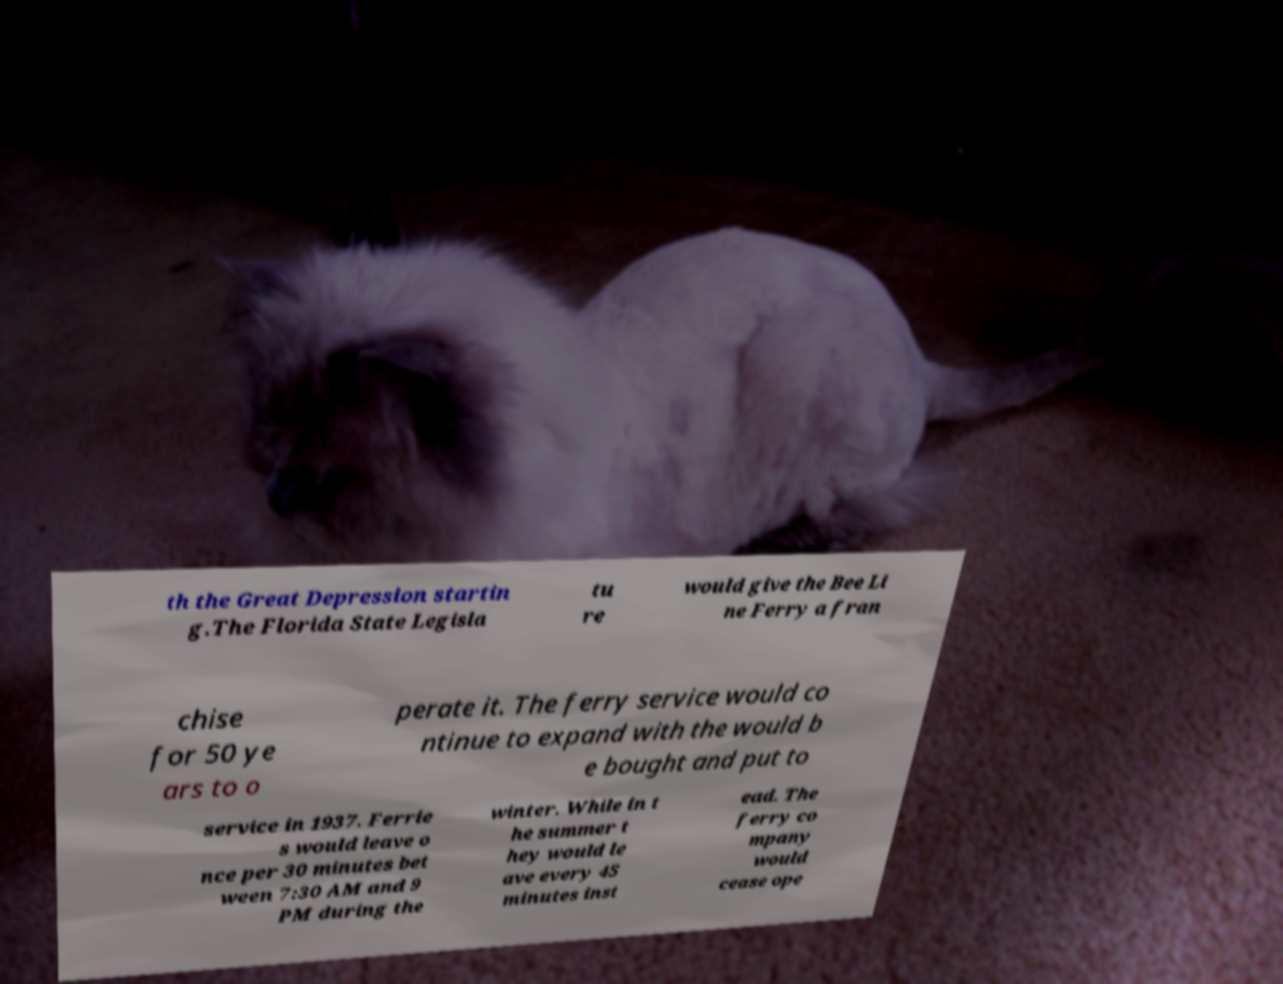Can you read and provide the text displayed in the image?This photo seems to have some interesting text. Can you extract and type it out for me? th the Great Depression startin g.The Florida State Legisla tu re would give the Bee Li ne Ferry a fran chise for 50 ye ars to o perate it. The ferry service would co ntinue to expand with the would b e bought and put to service in 1937. Ferrie s would leave o nce per 30 minutes bet ween 7:30 AM and 9 PM during the winter. While in t he summer t hey would le ave every 45 minutes inst ead. The ferry co mpany would cease ope 